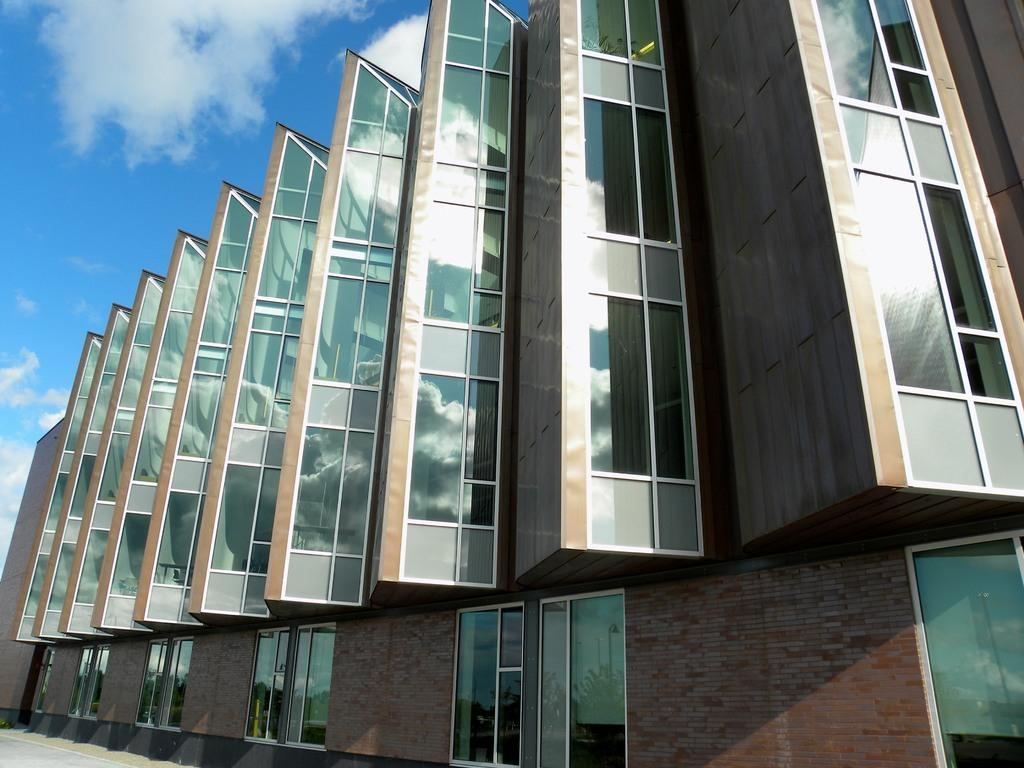What type of structure is present in the image? There is a building in the image. What can be seen in the background of the image? The sky is visible in the background of the image. How many rabbits can be seen hopping around the building in the image? There are no rabbits present in the image; it only features a building and the sky. What type of surprise is waiting for the viewer in the image? There is no surprise present in the image; it simply shows a building and the sky. 